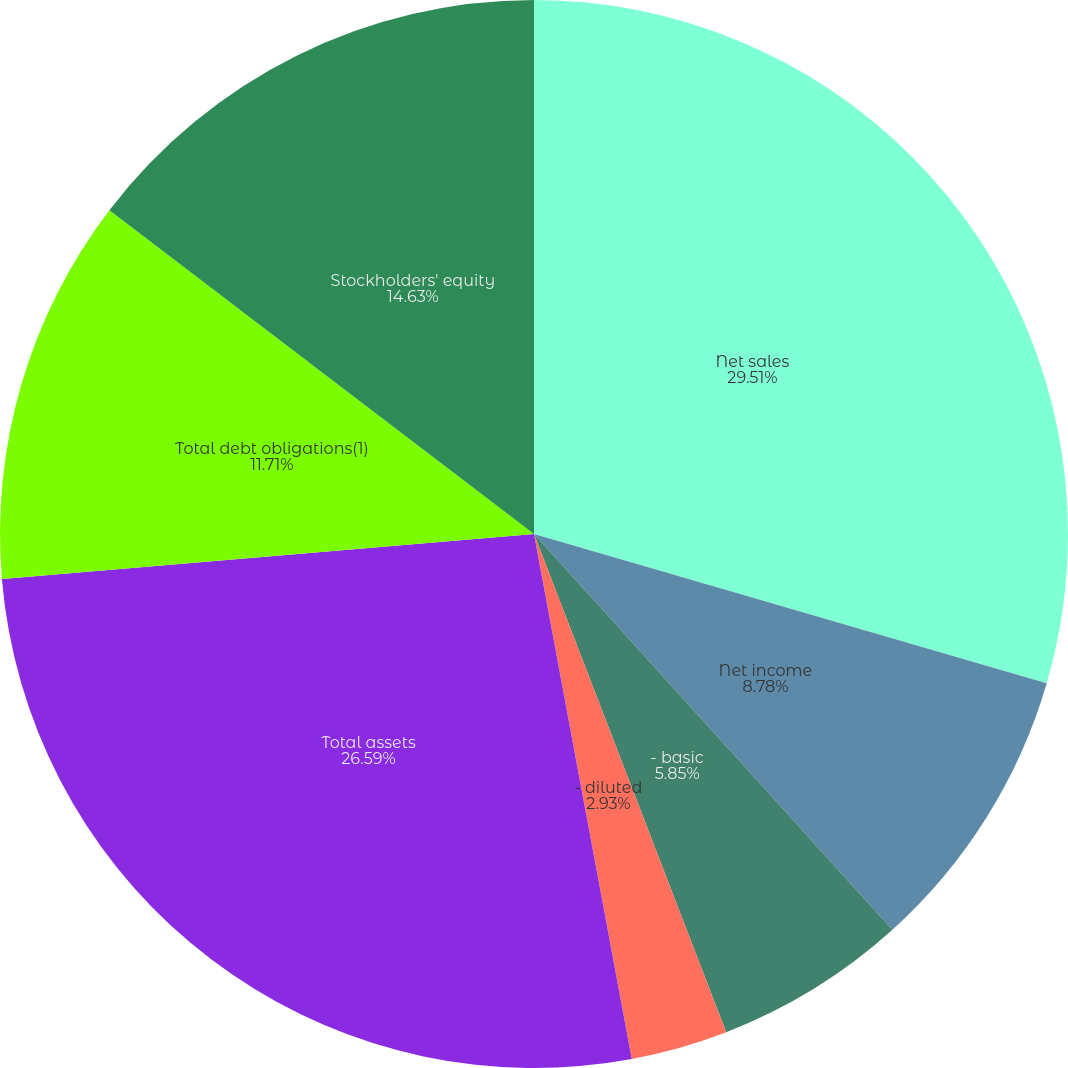<chart> <loc_0><loc_0><loc_500><loc_500><pie_chart><fcel>Net sales<fcel>Net income<fcel>- basic<fcel>- diluted<fcel>Cash dividends declared per<fcel>Total assets<fcel>Total debt obligations(1)<fcel>Stockholders' equity<nl><fcel>29.51%<fcel>8.78%<fcel>5.85%<fcel>2.93%<fcel>0.0%<fcel>26.59%<fcel>11.71%<fcel>14.63%<nl></chart> 